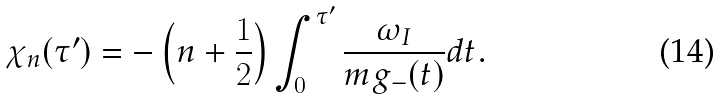Convert formula to latex. <formula><loc_0><loc_0><loc_500><loc_500>\chi _ { n } ( \tau ^ { \prime } ) = - \left ( n + \frac { 1 } { 2 } \right ) \int _ { 0 } ^ { \tau ^ { \prime } } \frac { \omega _ { I } } { m g _ { - } ( t ) } d t .</formula> 